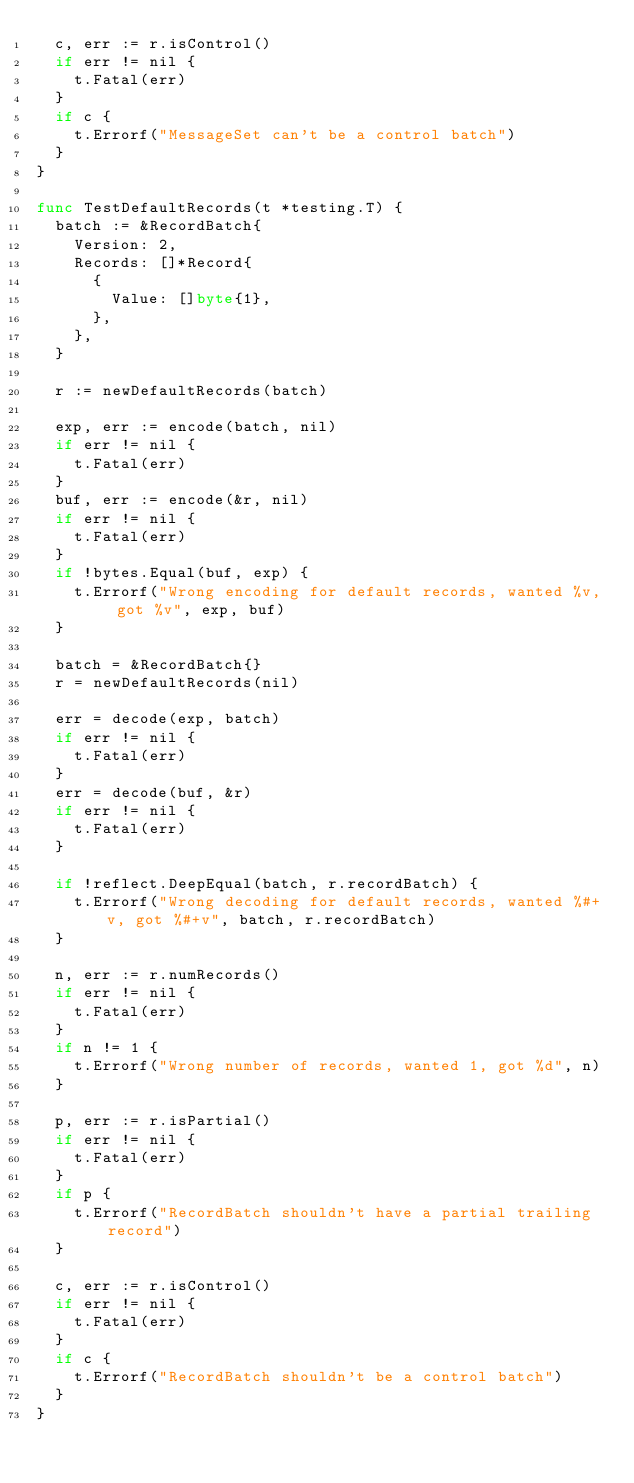Convert code to text. <code><loc_0><loc_0><loc_500><loc_500><_Go_>	c, err := r.isControl()
	if err != nil {
		t.Fatal(err)
	}
	if c {
		t.Errorf("MessageSet can't be a control batch")
	}
}

func TestDefaultRecords(t *testing.T) {
	batch := &RecordBatch{
		Version: 2,
		Records: []*Record{
			{
				Value: []byte{1},
			},
		},
	}

	r := newDefaultRecords(batch)

	exp, err := encode(batch, nil)
	if err != nil {
		t.Fatal(err)
	}
	buf, err := encode(&r, nil)
	if err != nil {
		t.Fatal(err)
	}
	if !bytes.Equal(buf, exp) {
		t.Errorf("Wrong encoding for default records, wanted %v, got %v", exp, buf)
	}

	batch = &RecordBatch{}
	r = newDefaultRecords(nil)

	err = decode(exp, batch)
	if err != nil {
		t.Fatal(err)
	}
	err = decode(buf, &r)
	if err != nil {
		t.Fatal(err)
	}

	if !reflect.DeepEqual(batch, r.recordBatch) {
		t.Errorf("Wrong decoding for default records, wanted %#+v, got %#+v", batch, r.recordBatch)
	}

	n, err := r.numRecords()
	if err != nil {
		t.Fatal(err)
	}
	if n != 1 {
		t.Errorf("Wrong number of records, wanted 1, got %d", n)
	}

	p, err := r.isPartial()
	if err != nil {
		t.Fatal(err)
	}
	if p {
		t.Errorf("RecordBatch shouldn't have a partial trailing record")
	}

	c, err := r.isControl()
	if err != nil {
		t.Fatal(err)
	}
	if c {
		t.Errorf("RecordBatch shouldn't be a control batch")
	}
}
</code> 